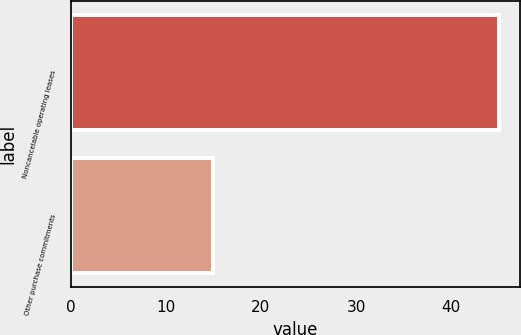Convert chart to OTSL. <chart><loc_0><loc_0><loc_500><loc_500><bar_chart><fcel>Noncancelable operating leases<fcel>Other purchase commitments<nl><fcel>45<fcel>15<nl></chart> 